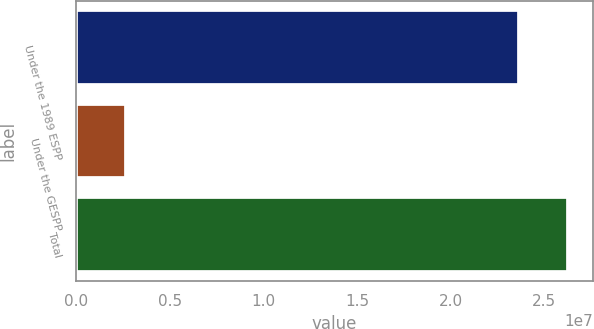<chart> <loc_0><loc_0><loc_500><loc_500><bar_chart><fcel>Under the 1989 ESPP<fcel>Under the GESPP<fcel>Total<nl><fcel>2.36312e+07<fcel>2.66007e+06<fcel>2.62913e+07<nl></chart> 